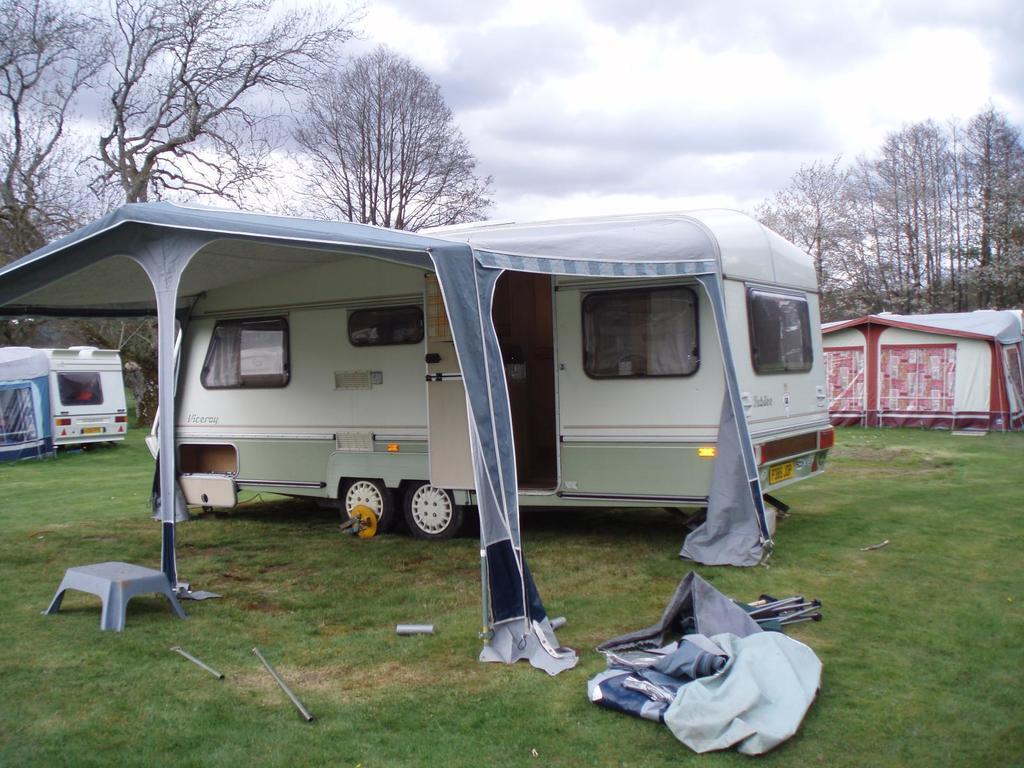Could you give a brief overview of what you see in this image? In this picture there is a tent in the center of the image on the grassland and there is a vehicle in the center of the image and there are other tents and a vehicle in the image and there are trees in the background area of the image. 